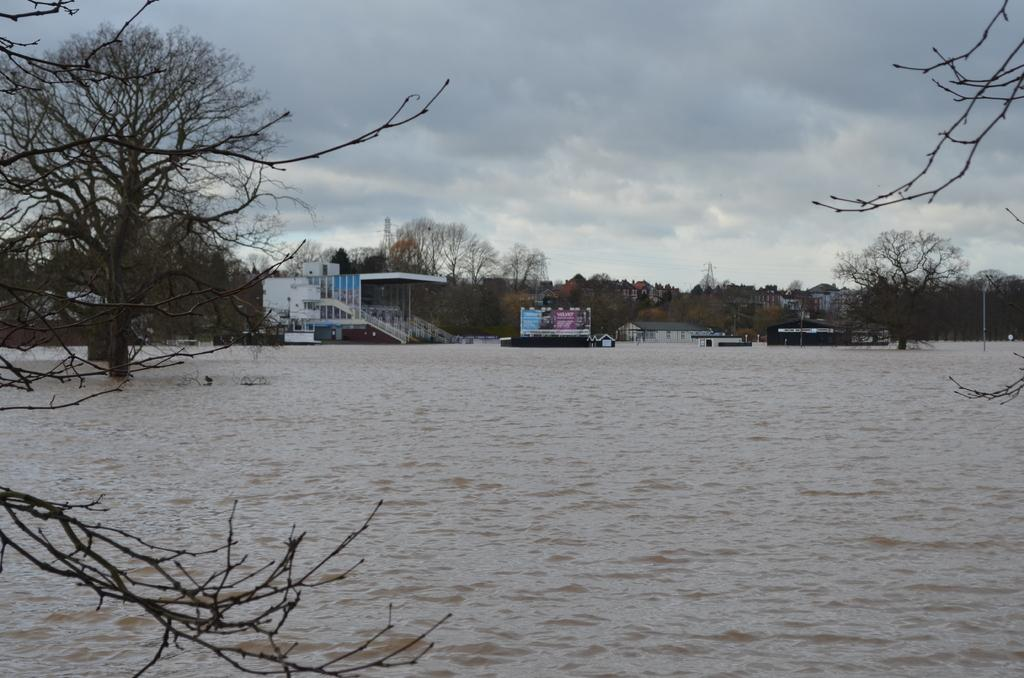What can be seen in the background of the image? In the background of the image, there are clouds in the sky, trees, buildings, an advertisement, towers, and street poles. What is visible in the foreground of the image? There is water visible in the foreground of the image. What type of wire is being used to hold the box in the image? There is no box or wire present in the image. How does the burn on the person's hand look in the image? There is no burn or person present in the image. 